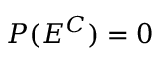Convert formula to latex. <formula><loc_0><loc_0><loc_500><loc_500>P ( E ^ { C } ) = 0</formula> 